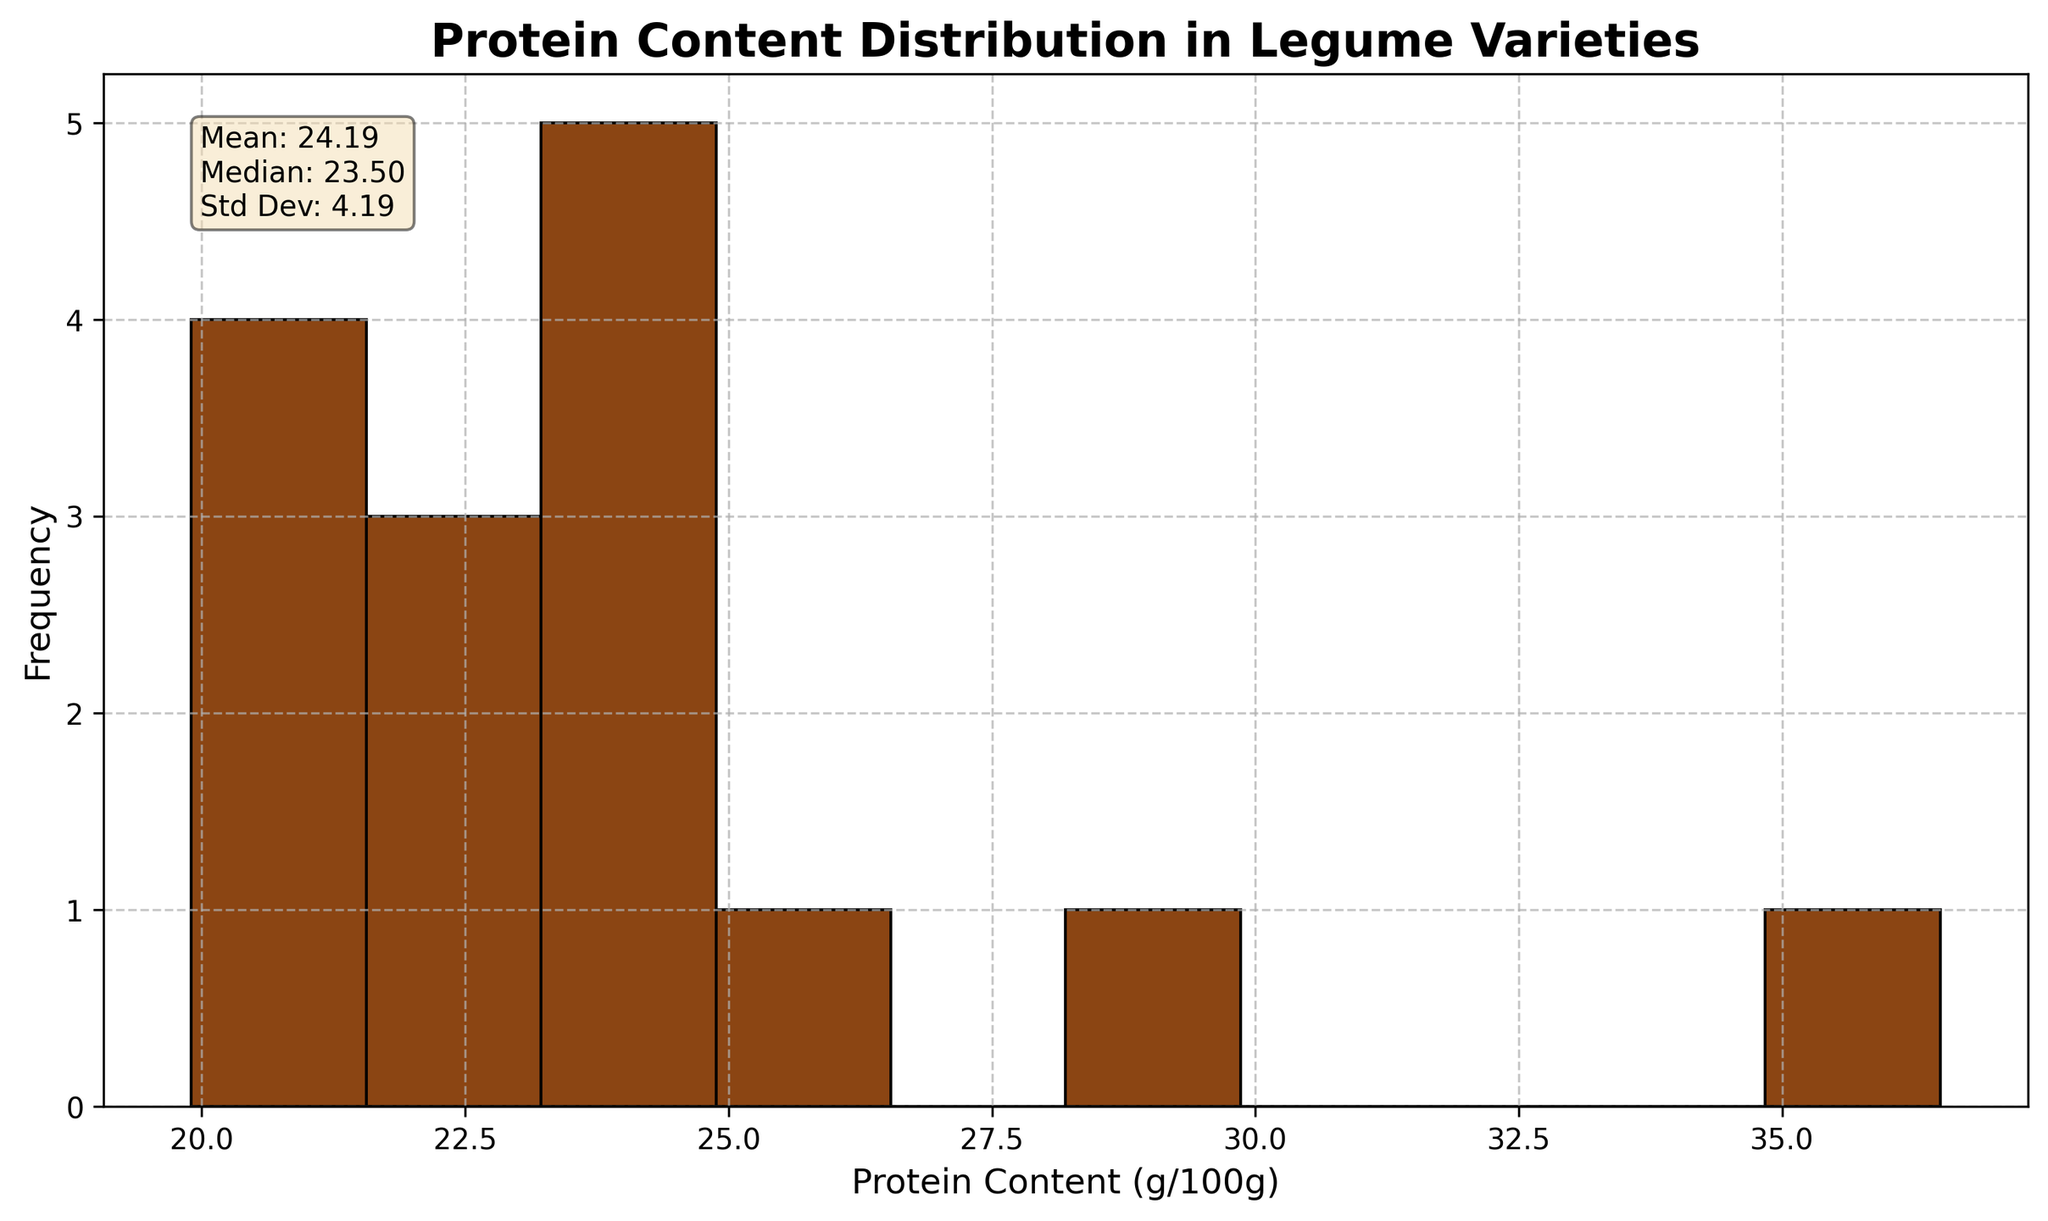What's the title of the histogram? The title is displayed at the top of the histogram. It reads "Protein Content Distribution in Legume Varieties."
Answer: Protein Content Distribution in Legume Varieties How many bins are there in the histogram? The histogram has bins of protein content values, demarcated by the black edges. Counting these bins, we get a total of 10 bins.
Answer: 10 What is the mean protein content displayed in the text box? The mean protein content is given in the statistics text box. It states "Mean: 24.43".
Answer: 24.43 Which protein content bin has the highest frequency? Observing the heights of the bars, the bin with the base ranging from approximately 21 to 22 g/100g has the highest frequency.
Answer: 21-22 g/100g What is the protein content range of the legume with the highest protein content, and which legume is it? The text box states the range and the legumes in each bin. Soybean has the highest protein content at 36.5 g/100g.
Answer: 36.5 g/100g, Soybean What is the median protein content according to the text box? The median protein content is provided in the statistics text box. It reads "Median: 23.80".
Answer: 23.80 Compare the number of legumes in the lowest bin (below 20 g/100g) to the bin with the highest frequency. The lowest bin has 1 legume (19.9 g/100g), and the highest frequency bin (21-22 g/100g) has the most legumes. Observing the histogram bars, the bin with the highest frequency appears to have more legumes.
Answer: Highest frequency bin has more legumes What is the standard deviation of the protein content? The standard deviation is given in the statistics text box. It states "Std Dev: 4.69".
Answer: 4.69 Which two bins have the same frequency, and what is this frequency? Observing the equal bar heights, the bins approx 23-24 and 24-25 g/100g have similar frequencies. Counting the height, this frequency is 2.
Answer: 2 Between which two specific protein content ranges is the maximum frequency observed, and what might this indicate about the legume varieties? The most frequent occurrence is between 21 and 22 g/100g, as the highest bar is located there. This indicates many legumes cluster around this protein content range.
Answer: 21 and 22 g/100g 